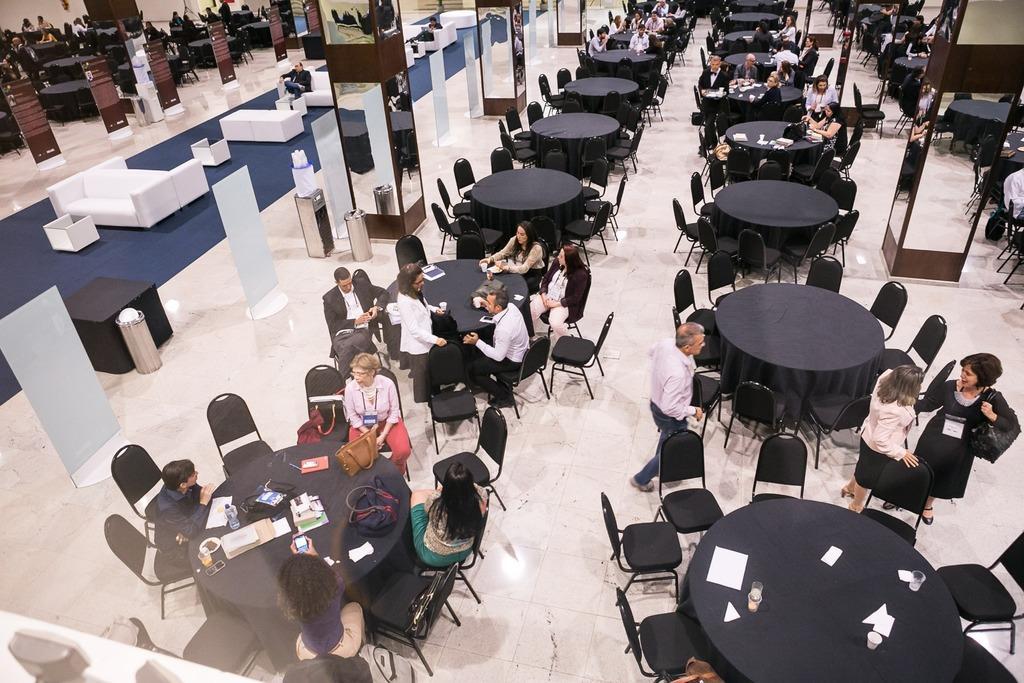In one or two sentences, can you explain what this image depicts? In this image I can see number of people, chairs and tables. I can also see sofas, dustbins and mirrors on all pillar. 